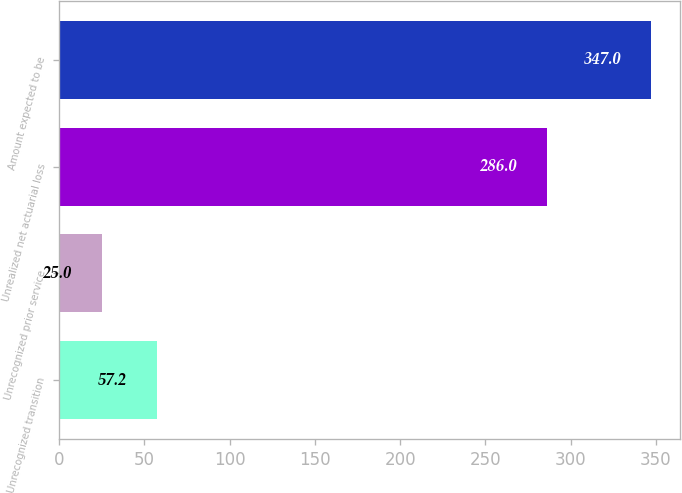<chart> <loc_0><loc_0><loc_500><loc_500><bar_chart><fcel>Unrecognized transition<fcel>Unrecognized prior service<fcel>Unrealized net actuarial loss<fcel>Amount expected to be<nl><fcel>57.2<fcel>25<fcel>286<fcel>347<nl></chart> 